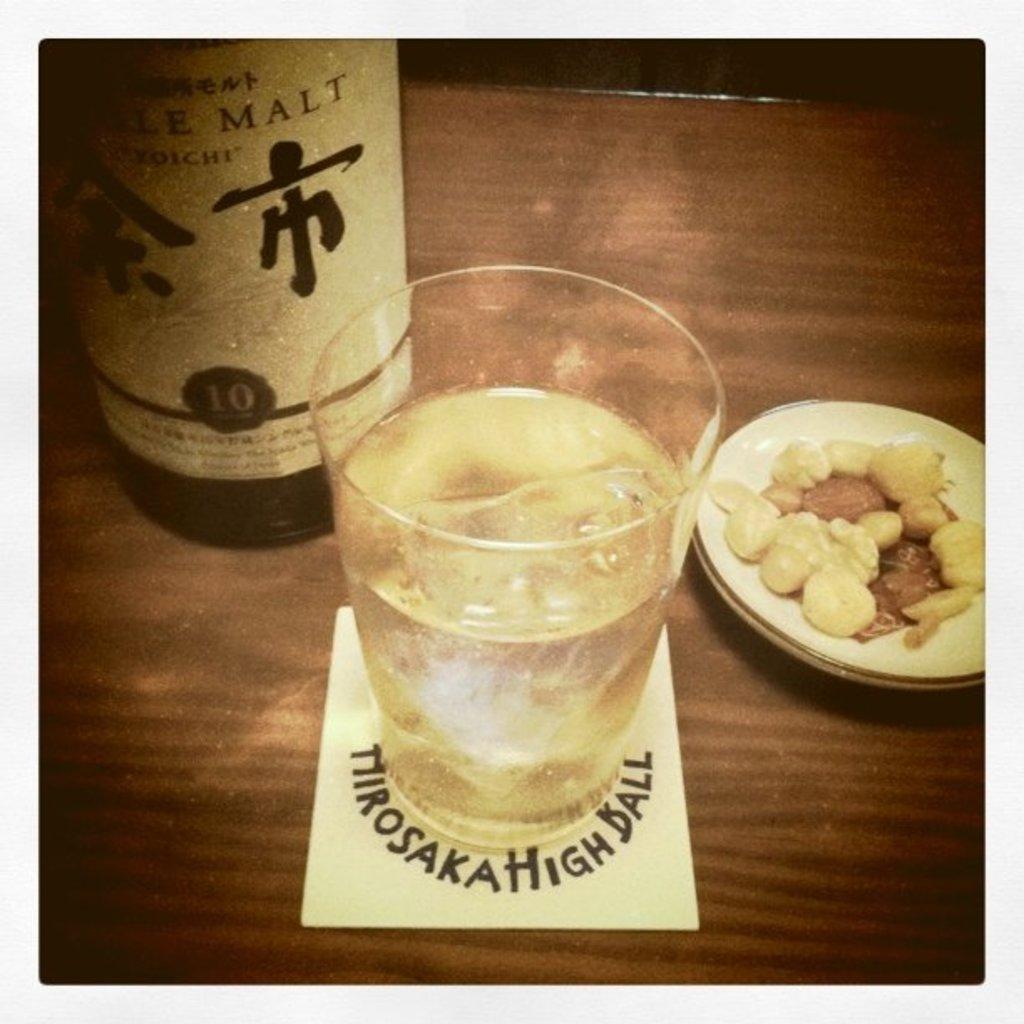What is the last word on the label above the character?
Give a very brief answer. Malt. 